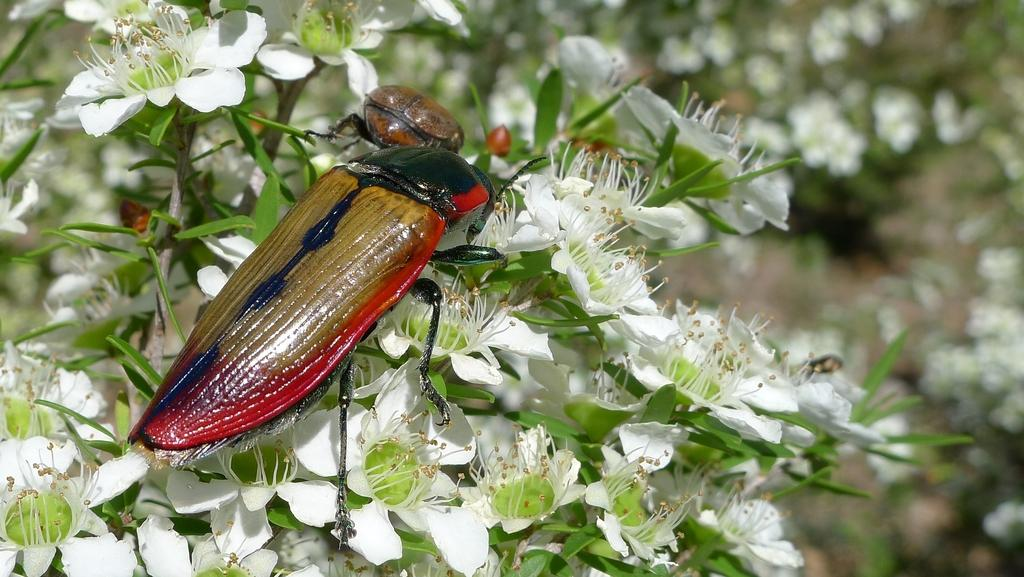What type of creature is in the image? There is an insect in the image. What colors can be seen on the insect? The insect has brown and red colors. What is the insect sitting on? The insect is sitting on a flower. What colors can be seen on the flower? The flower has white and green colors. How would you describe the background of the image? The background of the image is blurred. What type of dolls are present in the image? There are no dolls present in the image; it features an insect sitting on a flower. What beliefs are being expressed in the image? The image does not depict any beliefs or express any opinions. 